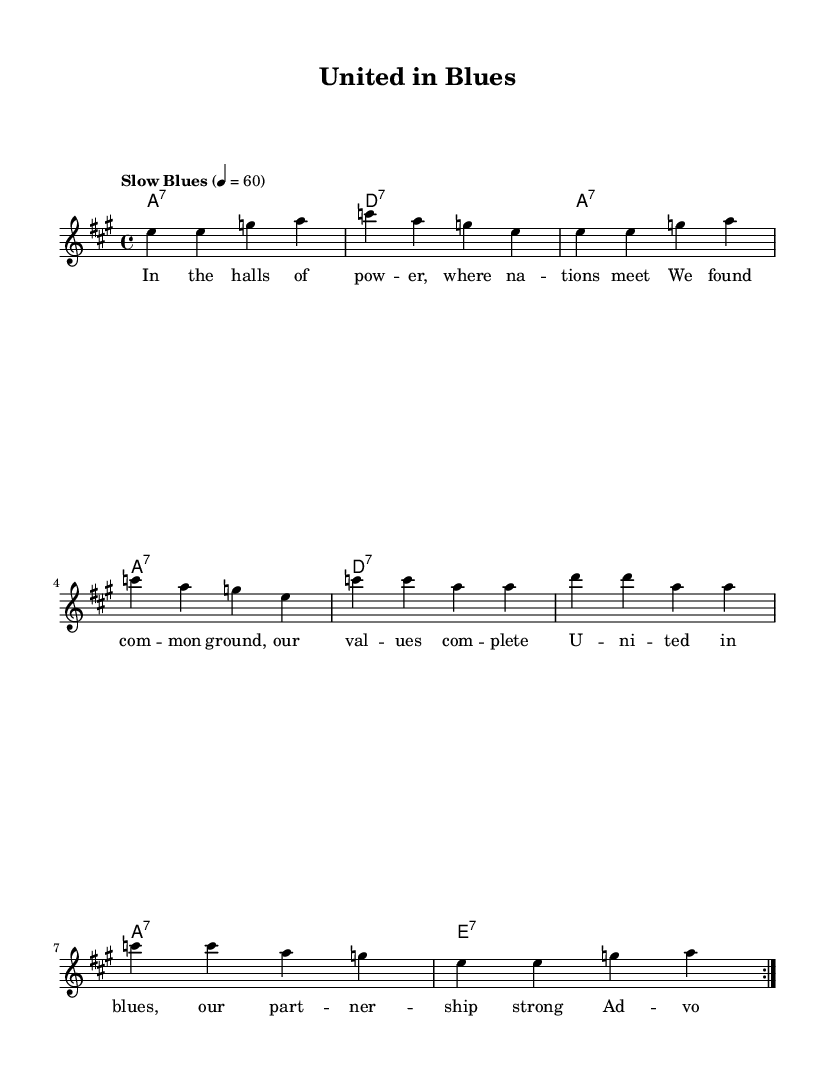What is the key signature of this music? The key signature is A major, which has three sharps (F#, C#, and G#). This can be identified from the key indication at the beginning of the score.
Answer: A major What is the time signature of this piece? The time signature is 4/4, indicated at the beginning of the score. This shows that there are four beats in each measure, and the quarter note gets one beat.
Answer: 4/4 What is the tempo marking of this piece? The tempo marking is "Slow Blues," which is specified alongside the metronome marking of 60 beats per minute. This indicates the desired speed for performing the piece.
Answer: Slow Blues How many measures are repeated in the melody? The melody contains a repeat indication for two measures, specified by the "repeat volta 2" directive at the beginning of the phrase. This means the first section within these measures is played two times.
Answer: 2 What type of seventh chords are used in the harmonies? The harmonies feature dominant seventh chords, which are indicated by the chord symbols (a:7, d:7, e:7) showing they are all based on the respective root notes and include the major triad and a minor seventh.
Answer: Dominant seventh chords What are the opening lyrics of the verse? The opening lyrics of the verse are "In the halls of pow -- er, where na -- tions meet," as they are written in the lyric mode under the melody line.
Answer: In the halls of power, where nations meet What thematic element is celebrated in this blues ballad? The thematic element celebrated in this blues ballad is partnership and shared values among nations, as expressed in both the lyrics and the overall message of unity in the music.
Answer: Partnership and shared values 